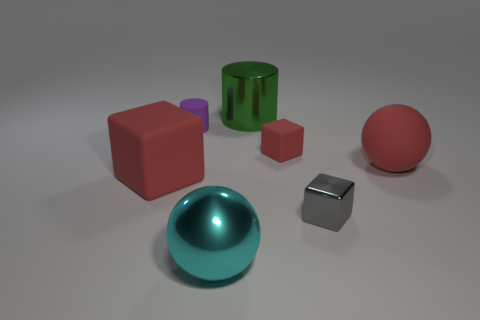What number of other objects are there of the same shape as the small gray thing?
Ensure brevity in your answer.  2. What is the ball to the right of the thing that is behind the tiny purple matte object made of?
Make the answer very short. Rubber. Do the green shiny object and the cyan metallic ball have the same size?
Ensure brevity in your answer.  Yes. How many tiny objects are blue metallic blocks or green cylinders?
Ensure brevity in your answer.  0. What number of objects are to the left of the cyan metallic object?
Offer a very short reply. 2. Are there more tiny objects to the left of the gray cube than tiny brown cubes?
Make the answer very short. Yes. There is another small object that is made of the same material as the tiny red thing; what shape is it?
Your response must be concise. Cylinder. There is a large shiny thing in front of the large metal thing on the right side of the cyan object; what color is it?
Ensure brevity in your answer.  Cyan. Does the tiny red object have the same shape as the gray metallic object?
Offer a very short reply. Yes. There is a big green thing that is the same shape as the purple matte object; what is its material?
Your answer should be very brief. Metal. 